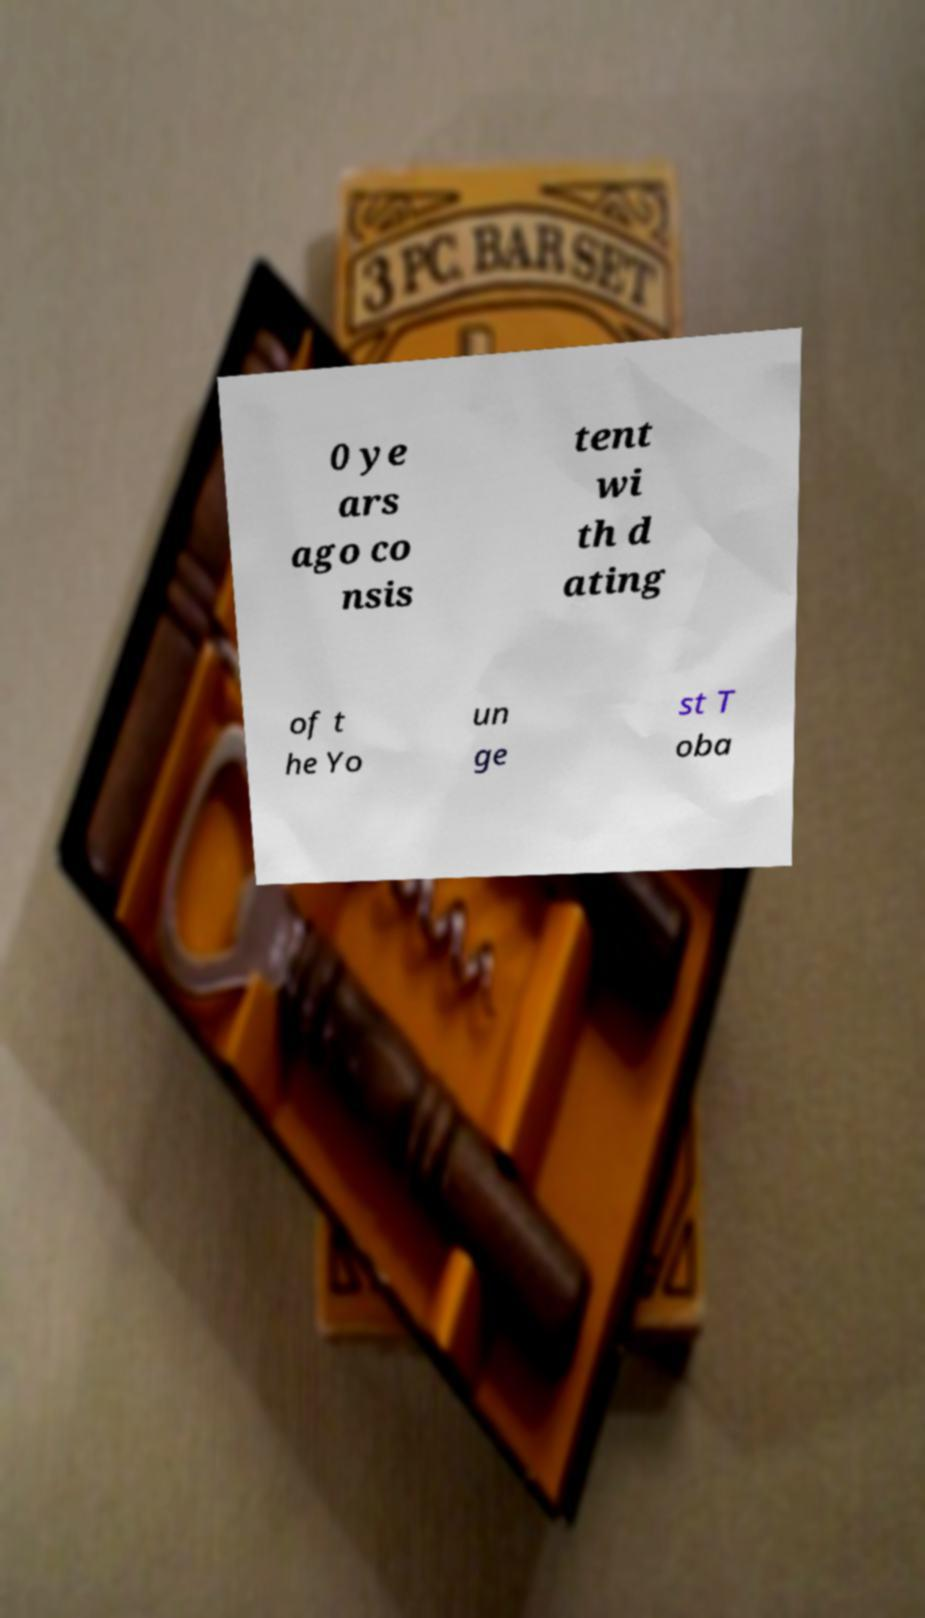There's text embedded in this image that I need extracted. Can you transcribe it verbatim? 0 ye ars ago co nsis tent wi th d ating of t he Yo un ge st T oba 